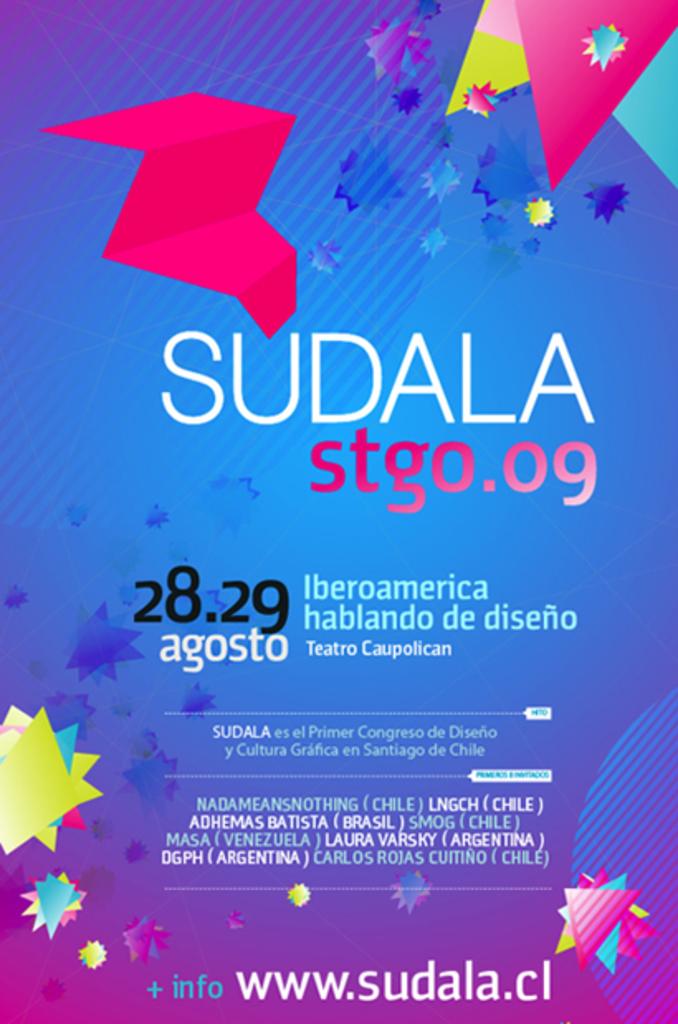What is the link shown on this poster?
Keep it short and to the point. Www.sudala.cl. Whats the name of the poster?
Provide a short and direct response. Sudala. 